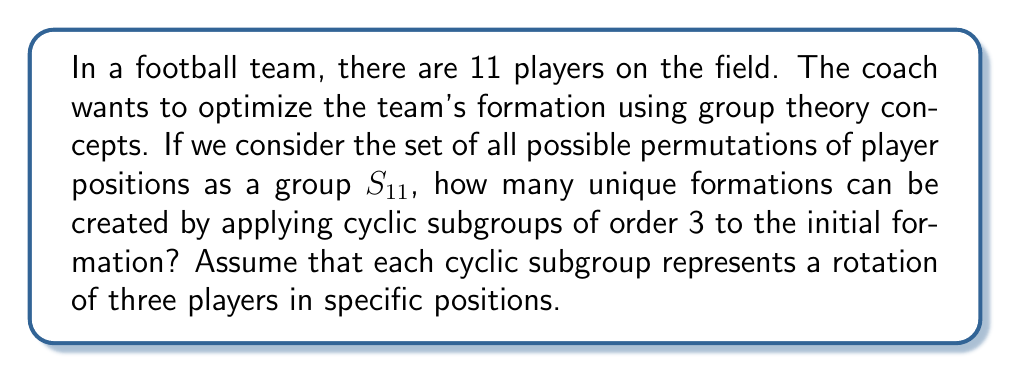Show me your answer to this math problem. Let's approach this step-by-step:

1) First, we need to understand what a cyclic subgroup of order 3 means in $S_{11}$. It represents a 3-cycle, or a rotation of three players.

2) In $S_{11}$, the number of 3-cycles is:

   $$\binom{11}{3} \cdot 2 = \frac{11!}{3!(11-3)!} \cdot 2 = \frac{11 \cdot 10 \cdot 9}{3 \cdot 2 \cdot 1} \cdot 2 = 330$$

3) However, not all of these 3-cycles will create unique formations. We need to consider the orbits of these 3-cycles.

4) Each 3-cycle generates two additional permutations besides the identity. For example, (123) also generates (231) and (312).

5) Therefore, the number of unique formations created by 3-cycles is:

   $$\frac{330}{3} = 110$$

6) However, we also need to include the initial formation. So the total number of unique formations is:

   $$110 + 1 = 111$$

This approach allows the coach to systematically explore different player combinations without the need for cumbersome manual calculations or relying on potentially unreliable online tools.
Answer: 111 unique formations 